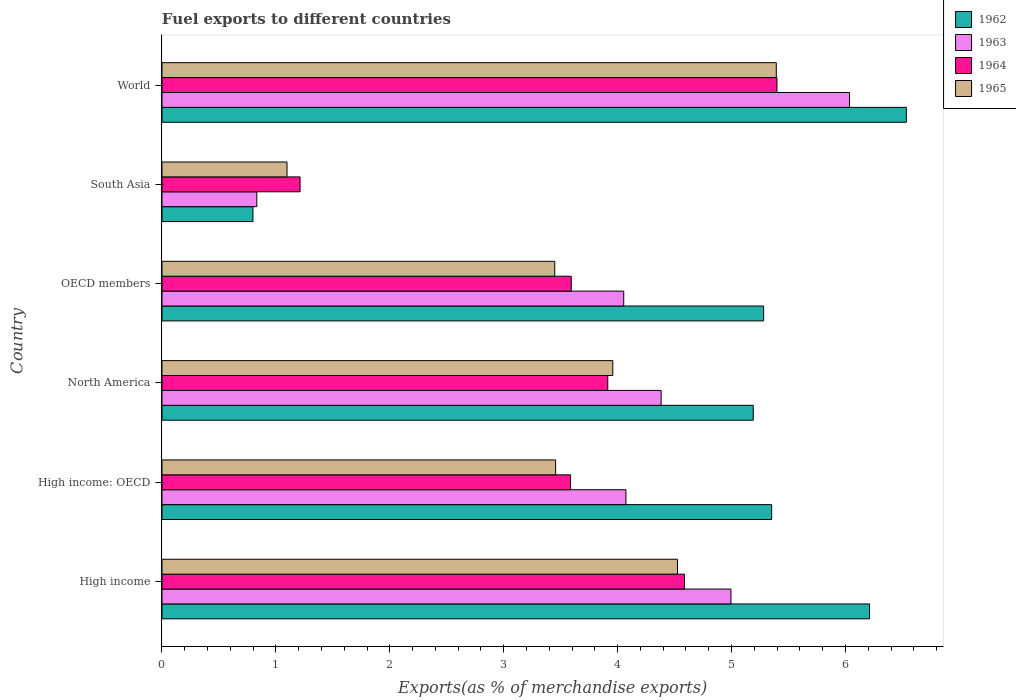How many different coloured bars are there?
Ensure brevity in your answer.  4. How many groups of bars are there?
Keep it short and to the point. 6. Are the number of bars per tick equal to the number of legend labels?
Keep it short and to the point. Yes. Are the number of bars on each tick of the Y-axis equal?
Give a very brief answer. Yes. How many bars are there on the 1st tick from the bottom?
Provide a short and direct response. 4. What is the label of the 2nd group of bars from the top?
Provide a short and direct response. South Asia. What is the percentage of exports to different countries in 1963 in South Asia?
Offer a terse response. 0.83. Across all countries, what is the maximum percentage of exports to different countries in 1965?
Provide a succinct answer. 5.39. Across all countries, what is the minimum percentage of exports to different countries in 1965?
Keep it short and to the point. 1.1. What is the total percentage of exports to different countries in 1963 in the graph?
Offer a very short reply. 24.37. What is the difference between the percentage of exports to different countries in 1962 in High income and that in World?
Ensure brevity in your answer.  -0.32. What is the difference between the percentage of exports to different countries in 1965 in World and the percentage of exports to different countries in 1963 in High income: OECD?
Make the answer very short. 1.32. What is the average percentage of exports to different countries in 1965 per country?
Keep it short and to the point. 3.65. What is the difference between the percentage of exports to different countries in 1963 and percentage of exports to different countries in 1965 in High income: OECD?
Provide a short and direct response. 0.62. In how many countries, is the percentage of exports to different countries in 1962 greater than 1.6 %?
Provide a succinct answer. 5. What is the ratio of the percentage of exports to different countries in 1964 in OECD members to that in World?
Your answer should be very brief. 0.67. Is the percentage of exports to different countries in 1965 in High income less than that in World?
Make the answer very short. Yes. What is the difference between the highest and the second highest percentage of exports to different countries in 1965?
Provide a succinct answer. 0.87. What is the difference between the highest and the lowest percentage of exports to different countries in 1964?
Your answer should be very brief. 4.19. In how many countries, is the percentage of exports to different countries in 1965 greater than the average percentage of exports to different countries in 1965 taken over all countries?
Make the answer very short. 3. What does the 2nd bar from the top in High income: OECD represents?
Give a very brief answer. 1964. What does the 3rd bar from the bottom in High income represents?
Your answer should be compact. 1964. Are all the bars in the graph horizontal?
Your answer should be compact. Yes. How many countries are there in the graph?
Your response must be concise. 6. What is the difference between two consecutive major ticks on the X-axis?
Your response must be concise. 1. Does the graph contain any zero values?
Offer a terse response. No. Where does the legend appear in the graph?
Offer a terse response. Top right. How are the legend labels stacked?
Provide a short and direct response. Vertical. What is the title of the graph?
Offer a very short reply. Fuel exports to different countries. What is the label or title of the X-axis?
Make the answer very short. Exports(as % of merchandise exports). What is the Exports(as % of merchandise exports) in 1962 in High income?
Offer a very short reply. 6.21. What is the Exports(as % of merchandise exports) in 1963 in High income?
Make the answer very short. 5. What is the Exports(as % of merchandise exports) in 1964 in High income?
Give a very brief answer. 4.59. What is the Exports(as % of merchandise exports) in 1965 in High income?
Your response must be concise. 4.53. What is the Exports(as % of merchandise exports) in 1962 in High income: OECD?
Your answer should be compact. 5.35. What is the Exports(as % of merchandise exports) in 1963 in High income: OECD?
Give a very brief answer. 4.07. What is the Exports(as % of merchandise exports) in 1964 in High income: OECD?
Keep it short and to the point. 3.59. What is the Exports(as % of merchandise exports) in 1965 in High income: OECD?
Give a very brief answer. 3.46. What is the Exports(as % of merchandise exports) in 1962 in North America?
Your response must be concise. 5.19. What is the Exports(as % of merchandise exports) in 1963 in North America?
Keep it short and to the point. 4.38. What is the Exports(as % of merchandise exports) in 1964 in North America?
Your answer should be compact. 3.91. What is the Exports(as % of merchandise exports) of 1965 in North America?
Provide a succinct answer. 3.96. What is the Exports(as % of merchandise exports) in 1962 in OECD members?
Give a very brief answer. 5.28. What is the Exports(as % of merchandise exports) in 1963 in OECD members?
Offer a very short reply. 4.05. What is the Exports(as % of merchandise exports) in 1964 in OECD members?
Your response must be concise. 3.59. What is the Exports(as % of merchandise exports) in 1965 in OECD members?
Your answer should be very brief. 3.45. What is the Exports(as % of merchandise exports) of 1962 in South Asia?
Offer a very short reply. 0.8. What is the Exports(as % of merchandise exports) in 1963 in South Asia?
Your response must be concise. 0.83. What is the Exports(as % of merchandise exports) in 1964 in South Asia?
Provide a short and direct response. 1.21. What is the Exports(as % of merchandise exports) in 1965 in South Asia?
Your answer should be very brief. 1.1. What is the Exports(as % of merchandise exports) in 1962 in World?
Give a very brief answer. 6.53. What is the Exports(as % of merchandise exports) of 1963 in World?
Keep it short and to the point. 6.04. What is the Exports(as % of merchandise exports) in 1964 in World?
Provide a short and direct response. 5.4. What is the Exports(as % of merchandise exports) in 1965 in World?
Provide a short and direct response. 5.39. Across all countries, what is the maximum Exports(as % of merchandise exports) in 1962?
Your answer should be compact. 6.53. Across all countries, what is the maximum Exports(as % of merchandise exports) of 1963?
Your response must be concise. 6.04. Across all countries, what is the maximum Exports(as % of merchandise exports) in 1964?
Provide a succinct answer. 5.4. Across all countries, what is the maximum Exports(as % of merchandise exports) in 1965?
Your answer should be very brief. 5.39. Across all countries, what is the minimum Exports(as % of merchandise exports) in 1962?
Offer a terse response. 0.8. Across all countries, what is the minimum Exports(as % of merchandise exports) of 1963?
Offer a very short reply. 0.83. Across all countries, what is the minimum Exports(as % of merchandise exports) in 1964?
Provide a short and direct response. 1.21. Across all countries, what is the minimum Exports(as % of merchandise exports) in 1965?
Keep it short and to the point. 1.1. What is the total Exports(as % of merchandise exports) of 1962 in the graph?
Provide a succinct answer. 29.37. What is the total Exports(as % of merchandise exports) of 1963 in the graph?
Provide a short and direct response. 24.37. What is the total Exports(as % of merchandise exports) in 1964 in the graph?
Provide a short and direct response. 22.29. What is the total Exports(as % of merchandise exports) of 1965 in the graph?
Provide a short and direct response. 21.88. What is the difference between the Exports(as % of merchandise exports) in 1962 in High income and that in High income: OECD?
Make the answer very short. 0.86. What is the difference between the Exports(as % of merchandise exports) of 1963 in High income and that in High income: OECD?
Your answer should be very brief. 0.92. What is the difference between the Exports(as % of merchandise exports) of 1964 in High income and that in High income: OECD?
Your response must be concise. 1. What is the difference between the Exports(as % of merchandise exports) in 1965 in High income and that in High income: OECD?
Provide a short and direct response. 1.07. What is the difference between the Exports(as % of merchandise exports) in 1963 in High income and that in North America?
Ensure brevity in your answer.  0.61. What is the difference between the Exports(as % of merchandise exports) of 1964 in High income and that in North America?
Provide a succinct answer. 0.67. What is the difference between the Exports(as % of merchandise exports) in 1965 in High income and that in North America?
Provide a succinct answer. 0.57. What is the difference between the Exports(as % of merchandise exports) of 1962 in High income and that in OECD members?
Offer a very short reply. 0.93. What is the difference between the Exports(as % of merchandise exports) of 1963 in High income and that in OECD members?
Give a very brief answer. 0.94. What is the difference between the Exports(as % of merchandise exports) in 1965 in High income and that in OECD members?
Give a very brief answer. 1.08. What is the difference between the Exports(as % of merchandise exports) of 1962 in High income and that in South Asia?
Ensure brevity in your answer.  5.41. What is the difference between the Exports(as % of merchandise exports) in 1963 in High income and that in South Asia?
Keep it short and to the point. 4.16. What is the difference between the Exports(as % of merchandise exports) of 1964 in High income and that in South Asia?
Make the answer very short. 3.37. What is the difference between the Exports(as % of merchandise exports) in 1965 in High income and that in South Asia?
Provide a short and direct response. 3.43. What is the difference between the Exports(as % of merchandise exports) of 1962 in High income and that in World?
Offer a terse response. -0.32. What is the difference between the Exports(as % of merchandise exports) of 1963 in High income and that in World?
Provide a succinct answer. -1.04. What is the difference between the Exports(as % of merchandise exports) of 1964 in High income and that in World?
Make the answer very short. -0.81. What is the difference between the Exports(as % of merchandise exports) in 1965 in High income and that in World?
Provide a succinct answer. -0.87. What is the difference between the Exports(as % of merchandise exports) in 1962 in High income: OECD and that in North America?
Offer a very short reply. 0.16. What is the difference between the Exports(as % of merchandise exports) of 1963 in High income: OECD and that in North America?
Ensure brevity in your answer.  -0.31. What is the difference between the Exports(as % of merchandise exports) of 1964 in High income: OECD and that in North America?
Make the answer very short. -0.33. What is the difference between the Exports(as % of merchandise exports) in 1965 in High income: OECD and that in North America?
Your response must be concise. -0.5. What is the difference between the Exports(as % of merchandise exports) of 1962 in High income: OECD and that in OECD members?
Your answer should be compact. 0.07. What is the difference between the Exports(as % of merchandise exports) in 1963 in High income: OECD and that in OECD members?
Your answer should be compact. 0.02. What is the difference between the Exports(as % of merchandise exports) of 1964 in High income: OECD and that in OECD members?
Make the answer very short. -0.01. What is the difference between the Exports(as % of merchandise exports) in 1965 in High income: OECD and that in OECD members?
Offer a very short reply. 0.01. What is the difference between the Exports(as % of merchandise exports) in 1962 in High income: OECD and that in South Asia?
Your answer should be compact. 4.55. What is the difference between the Exports(as % of merchandise exports) in 1963 in High income: OECD and that in South Asia?
Give a very brief answer. 3.24. What is the difference between the Exports(as % of merchandise exports) in 1964 in High income: OECD and that in South Asia?
Provide a short and direct response. 2.37. What is the difference between the Exports(as % of merchandise exports) in 1965 in High income: OECD and that in South Asia?
Ensure brevity in your answer.  2.36. What is the difference between the Exports(as % of merchandise exports) of 1962 in High income: OECD and that in World?
Provide a short and direct response. -1.18. What is the difference between the Exports(as % of merchandise exports) of 1963 in High income: OECD and that in World?
Provide a short and direct response. -1.96. What is the difference between the Exports(as % of merchandise exports) of 1964 in High income: OECD and that in World?
Your answer should be very brief. -1.81. What is the difference between the Exports(as % of merchandise exports) of 1965 in High income: OECD and that in World?
Give a very brief answer. -1.94. What is the difference between the Exports(as % of merchandise exports) in 1962 in North America and that in OECD members?
Your response must be concise. -0.09. What is the difference between the Exports(as % of merchandise exports) in 1963 in North America and that in OECD members?
Your answer should be compact. 0.33. What is the difference between the Exports(as % of merchandise exports) in 1964 in North America and that in OECD members?
Offer a terse response. 0.32. What is the difference between the Exports(as % of merchandise exports) in 1965 in North America and that in OECD members?
Make the answer very short. 0.51. What is the difference between the Exports(as % of merchandise exports) in 1962 in North America and that in South Asia?
Your answer should be compact. 4.39. What is the difference between the Exports(as % of merchandise exports) in 1963 in North America and that in South Asia?
Ensure brevity in your answer.  3.55. What is the difference between the Exports(as % of merchandise exports) in 1964 in North America and that in South Asia?
Offer a terse response. 2.7. What is the difference between the Exports(as % of merchandise exports) in 1965 in North America and that in South Asia?
Provide a short and direct response. 2.86. What is the difference between the Exports(as % of merchandise exports) of 1962 in North America and that in World?
Provide a short and direct response. -1.34. What is the difference between the Exports(as % of merchandise exports) of 1963 in North America and that in World?
Keep it short and to the point. -1.65. What is the difference between the Exports(as % of merchandise exports) of 1964 in North America and that in World?
Your response must be concise. -1.49. What is the difference between the Exports(as % of merchandise exports) of 1965 in North America and that in World?
Give a very brief answer. -1.44. What is the difference between the Exports(as % of merchandise exports) in 1962 in OECD members and that in South Asia?
Give a very brief answer. 4.48. What is the difference between the Exports(as % of merchandise exports) in 1963 in OECD members and that in South Asia?
Ensure brevity in your answer.  3.22. What is the difference between the Exports(as % of merchandise exports) of 1964 in OECD members and that in South Asia?
Keep it short and to the point. 2.38. What is the difference between the Exports(as % of merchandise exports) of 1965 in OECD members and that in South Asia?
Offer a terse response. 2.35. What is the difference between the Exports(as % of merchandise exports) in 1962 in OECD members and that in World?
Provide a short and direct response. -1.25. What is the difference between the Exports(as % of merchandise exports) of 1963 in OECD members and that in World?
Keep it short and to the point. -1.98. What is the difference between the Exports(as % of merchandise exports) of 1964 in OECD members and that in World?
Offer a terse response. -1.81. What is the difference between the Exports(as % of merchandise exports) in 1965 in OECD members and that in World?
Your response must be concise. -1.94. What is the difference between the Exports(as % of merchandise exports) in 1962 in South Asia and that in World?
Your answer should be very brief. -5.74. What is the difference between the Exports(as % of merchandise exports) in 1963 in South Asia and that in World?
Offer a terse response. -5.2. What is the difference between the Exports(as % of merchandise exports) of 1964 in South Asia and that in World?
Your response must be concise. -4.19. What is the difference between the Exports(as % of merchandise exports) in 1965 in South Asia and that in World?
Offer a very short reply. -4.3. What is the difference between the Exports(as % of merchandise exports) in 1962 in High income and the Exports(as % of merchandise exports) in 1963 in High income: OECD?
Your answer should be very brief. 2.14. What is the difference between the Exports(as % of merchandise exports) of 1962 in High income and the Exports(as % of merchandise exports) of 1964 in High income: OECD?
Ensure brevity in your answer.  2.62. What is the difference between the Exports(as % of merchandise exports) in 1962 in High income and the Exports(as % of merchandise exports) in 1965 in High income: OECD?
Make the answer very short. 2.76. What is the difference between the Exports(as % of merchandise exports) of 1963 in High income and the Exports(as % of merchandise exports) of 1964 in High income: OECD?
Make the answer very short. 1.41. What is the difference between the Exports(as % of merchandise exports) in 1963 in High income and the Exports(as % of merchandise exports) in 1965 in High income: OECD?
Offer a terse response. 1.54. What is the difference between the Exports(as % of merchandise exports) of 1964 in High income and the Exports(as % of merchandise exports) of 1965 in High income: OECD?
Your response must be concise. 1.13. What is the difference between the Exports(as % of merchandise exports) of 1962 in High income and the Exports(as % of merchandise exports) of 1963 in North America?
Give a very brief answer. 1.83. What is the difference between the Exports(as % of merchandise exports) of 1962 in High income and the Exports(as % of merchandise exports) of 1964 in North America?
Offer a very short reply. 2.3. What is the difference between the Exports(as % of merchandise exports) of 1962 in High income and the Exports(as % of merchandise exports) of 1965 in North America?
Provide a succinct answer. 2.25. What is the difference between the Exports(as % of merchandise exports) in 1963 in High income and the Exports(as % of merchandise exports) in 1964 in North America?
Give a very brief answer. 1.08. What is the difference between the Exports(as % of merchandise exports) in 1963 in High income and the Exports(as % of merchandise exports) in 1965 in North America?
Offer a terse response. 1.04. What is the difference between the Exports(as % of merchandise exports) of 1964 in High income and the Exports(as % of merchandise exports) of 1965 in North America?
Offer a very short reply. 0.63. What is the difference between the Exports(as % of merchandise exports) of 1962 in High income and the Exports(as % of merchandise exports) of 1963 in OECD members?
Provide a succinct answer. 2.16. What is the difference between the Exports(as % of merchandise exports) in 1962 in High income and the Exports(as % of merchandise exports) in 1964 in OECD members?
Provide a succinct answer. 2.62. What is the difference between the Exports(as % of merchandise exports) of 1962 in High income and the Exports(as % of merchandise exports) of 1965 in OECD members?
Offer a very short reply. 2.76. What is the difference between the Exports(as % of merchandise exports) in 1963 in High income and the Exports(as % of merchandise exports) in 1964 in OECD members?
Your answer should be very brief. 1.4. What is the difference between the Exports(as % of merchandise exports) of 1963 in High income and the Exports(as % of merchandise exports) of 1965 in OECD members?
Give a very brief answer. 1.55. What is the difference between the Exports(as % of merchandise exports) in 1964 in High income and the Exports(as % of merchandise exports) in 1965 in OECD members?
Provide a succinct answer. 1.14. What is the difference between the Exports(as % of merchandise exports) of 1962 in High income and the Exports(as % of merchandise exports) of 1963 in South Asia?
Ensure brevity in your answer.  5.38. What is the difference between the Exports(as % of merchandise exports) of 1962 in High income and the Exports(as % of merchandise exports) of 1964 in South Asia?
Make the answer very short. 5. What is the difference between the Exports(as % of merchandise exports) in 1962 in High income and the Exports(as % of merchandise exports) in 1965 in South Asia?
Keep it short and to the point. 5.11. What is the difference between the Exports(as % of merchandise exports) in 1963 in High income and the Exports(as % of merchandise exports) in 1964 in South Asia?
Make the answer very short. 3.78. What is the difference between the Exports(as % of merchandise exports) of 1963 in High income and the Exports(as % of merchandise exports) of 1965 in South Asia?
Make the answer very short. 3.9. What is the difference between the Exports(as % of merchandise exports) in 1964 in High income and the Exports(as % of merchandise exports) in 1965 in South Asia?
Provide a short and direct response. 3.49. What is the difference between the Exports(as % of merchandise exports) of 1962 in High income and the Exports(as % of merchandise exports) of 1963 in World?
Provide a succinct answer. 0.18. What is the difference between the Exports(as % of merchandise exports) of 1962 in High income and the Exports(as % of merchandise exports) of 1964 in World?
Make the answer very short. 0.81. What is the difference between the Exports(as % of merchandise exports) in 1962 in High income and the Exports(as % of merchandise exports) in 1965 in World?
Offer a terse response. 0.82. What is the difference between the Exports(as % of merchandise exports) of 1963 in High income and the Exports(as % of merchandise exports) of 1964 in World?
Your response must be concise. -0.4. What is the difference between the Exports(as % of merchandise exports) of 1963 in High income and the Exports(as % of merchandise exports) of 1965 in World?
Provide a short and direct response. -0.4. What is the difference between the Exports(as % of merchandise exports) of 1964 in High income and the Exports(as % of merchandise exports) of 1965 in World?
Ensure brevity in your answer.  -0.81. What is the difference between the Exports(as % of merchandise exports) in 1962 in High income: OECD and the Exports(as % of merchandise exports) in 1963 in North America?
Ensure brevity in your answer.  0.97. What is the difference between the Exports(as % of merchandise exports) of 1962 in High income: OECD and the Exports(as % of merchandise exports) of 1964 in North America?
Keep it short and to the point. 1.44. What is the difference between the Exports(as % of merchandise exports) of 1962 in High income: OECD and the Exports(as % of merchandise exports) of 1965 in North America?
Offer a very short reply. 1.39. What is the difference between the Exports(as % of merchandise exports) of 1963 in High income: OECD and the Exports(as % of merchandise exports) of 1964 in North America?
Provide a succinct answer. 0.16. What is the difference between the Exports(as % of merchandise exports) in 1963 in High income: OECD and the Exports(as % of merchandise exports) in 1965 in North America?
Ensure brevity in your answer.  0.12. What is the difference between the Exports(as % of merchandise exports) of 1964 in High income: OECD and the Exports(as % of merchandise exports) of 1965 in North America?
Give a very brief answer. -0.37. What is the difference between the Exports(as % of merchandise exports) in 1962 in High income: OECD and the Exports(as % of merchandise exports) in 1963 in OECD members?
Your answer should be very brief. 1.3. What is the difference between the Exports(as % of merchandise exports) of 1962 in High income: OECD and the Exports(as % of merchandise exports) of 1964 in OECD members?
Your answer should be very brief. 1.76. What is the difference between the Exports(as % of merchandise exports) of 1962 in High income: OECD and the Exports(as % of merchandise exports) of 1965 in OECD members?
Ensure brevity in your answer.  1.9. What is the difference between the Exports(as % of merchandise exports) of 1963 in High income: OECD and the Exports(as % of merchandise exports) of 1964 in OECD members?
Offer a very short reply. 0.48. What is the difference between the Exports(as % of merchandise exports) of 1963 in High income: OECD and the Exports(as % of merchandise exports) of 1965 in OECD members?
Ensure brevity in your answer.  0.62. What is the difference between the Exports(as % of merchandise exports) in 1964 in High income: OECD and the Exports(as % of merchandise exports) in 1965 in OECD members?
Your answer should be compact. 0.14. What is the difference between the Exports(as % of merchandise exports) of 1962 in High income: OECD and the Exports(as % of merchandise exports) of 1963 in South Asia?
Provide a short and direct response. 4.52. What is the difference between the Exports(as % of merchandise exports) in 1962 in High income: OECD and the Exports(as % of merchandise exports) in 1964 in South Asia?
Provide a short and direct response. 4.14. What is the difference between the Exports(as % of merchandise exports) of 1962 in High income: OECD and the Exports(as % of merchandise exports) of 1965 in South Asia?
Make the answer very short. 4.25. What is the difference between the Exports(as % of merchandise exports) of 1963 in High income: OECD and the Exports(as % of merchandise exports) of 1964 in South Asia?
Keep it short and to the point. 2.86. What is the difference between the Exports(as % of merchandise exports) of 1963 in High income: OECD and the Exports(as % of merchandise exports) of 1965 in South Asia?
Keep it short and to the point. 2.98. What is the difference between the Exports(as % of merchandise exports) of 1964 in High income: OECD and the Exports(as % of merchandise exports) of 1965 in South Asia?
Offer a very short reply. 2.49. What is the difference between the Exports(as % of merchandise exports) of 1962 in High income: OECD and the Exports(as % of merchandise exports) of 1963 in World?
Keep it short and to the point. -0.68. What is the difference between the Exports(as % of merchandise exports) in 1962 in High income: OECD and the Exports(as % of merchandise exports) in 1964 in World?
Offer a terse response. -0.05. What is the difference between the Exports(as % of merchandise exports) in 1962 in High income: OECD and the Exports(as % of merchandise exports) in 1965 in World?
Your response must be concise. -0.04. What is the difference between the Exports(as % of merchandise exports) in 1963 in High income: OECD and the Exports(as % of merchandise exports) in 1964 in World?
Your response must be concise. -1.33. What is the difference between the Exports(as % of merchandise exports) of 1963 in High income: OECD and the Exports(as % of merchandise exports) of 1965 in World?
Give a very brief answer. -1.32. What is the difference between the Exports(as % of merchandise exports) in 1964 in High income: OECD and the Exports(as % of merchandise exports) in 1965 in World?
Offer a very short reply. -1.81. What is the difference between the Exports(as % of merchandise exports) in 1962 in North America and the Exports(as % of merchandise exports) in 1963 in OECD members?
Offer a terse response. 1.14. What is the difference between the Exports(as % of merchandise exports) of 1962 in North America and the Exports(as % of merchandise exports) of 1964 in OECD members?
Keep it short and to the point. 1.6. What is the difference between the Exports(as % of merchandise exports) of 1962 in North America and the Exports(as % of merchandise exports) of 1965 in OECD members?
Keep it short and to the point. 1.74. What is the difference between the Exports(as % of merchandise exports) of 1963 in North America and the Exports(as % of merchandise exports) of 1964 in OECD members?
Your answer should be very brief. 0.79. What is the difference between the Exports(as % of merchandise exports) of 1963 in North America and the Exports(as % of merchandise exports) of 1965 in OECD members?
Make the answer very short. 0.93. What is the difference between the Exports(as % of merchandise exports) of 1964 in North America and the Exports(as % of merchandise exports) of 1965 in OECD members?
Keep it short and to the point. 0.47. What is the difference between the Exports(as % of merchandise exports) in 1962 in North America and the Exports(as % of merchandise exports) in 1963 in South Asia?
Keep it short and to the point. 4.36. What is the difference between the Exports(as % of merchandise exports) in 1962 in North America and the Exports(as % of merchandise exports) in 1964 in South Asia?
Offer a terse response. 3.98. What is the difference between the Exports(as % of merchandise exports) in 1962 in North America and the Exports(as % of merchandise exports) in 1965 in South Asia?
Make the answer very short. 4.09. What is the difference between the Exports(as % of merchandise exports) in 1963 in North America and the Exports(as % of merchandise exports) in 1964 in South Asia?
Make the answer very short. 3.17. What is the difference between the Exports(as % of merchandise exports) in 1963 in North America and the Exports(as % of merchandise exports) in 1965 in South Asia?
Provide a short and direct response. 3.28. What is the difference between the Exports(as % of merchandise exports) of 1964 in North America and the Exports(as % of merchandise exports) of 1965 in South Asia?
Give a very brief answer. 2.82. What is the difference between the Exports(as % of merchandise exports) in 1962 in North America and the Exports(as % of merchandise exports) in 1963 in World?
Your response must be concise. -0.85. What is the difference between the Exports(as % of merchandise exports) in 1962 in North America and the Exports(as % of merchandise exports) in 1964 in World?
Your response must be concise. -0.21. What is the difference between the Exports(as % of merchandise exports) of 1962 in North America and the Exports(as % of merchandise exports) of 1965 in World?
Your response must be concise. -0.2. What is the difference between the Exports(as % of merchandise exports) of 1963 in North America and the Exports(as % of merchandise exports) of 1964 in World?
Your answer should be compact. -1.02. What is the difference between the Exports(as % of merchandise exports) of 1963 in North America and the Exports(as % of merchandise exports) of 1965 in World?
Give a very brief answer. -1.01. What is the difference between the Exports(as % of merchandise exports) of 1964 in North America and the Exports(as % of merchandise exports) of 1965 in World?
Keep it short and to the point. -1.48. What is the difference between the Exports(as % of merchandise exports) of 1962 in OECD members and the Exports(as % of merchandise exports) of 1963 in South Asia?
Provide a succinct answer. 4.45. What is the difference between the Exports(as % of merchandise exports) of 1962 in OECD members and the Exports(as % of merchandise exports) of 1964 in South Asia?
Your response must be concise. 4.07. What is the difference between the Exports(as % of merchandise exports) in 1962 in OECD members and the Exports(as % of merchandise exports) in 1965 in South Asia?
Offer a very short reply. 4.18. What is the difference between the Exports(as % of merchandise exports) in 1963 in OECD members and the Exports(as % of merchandise exports) in 1964 in South Asia?
Offer a terse response. 2.84. What is the difference between the Exports(as % of merchandise exports) of 1963 in OECD members and the Exports(as % of merchandise exports) of 1965 in South Asia?
Provide a succinct answer. 2.96. What is the difference between the Exports(as % of merchandise exports) of 1964 in OECD members and the Exports(as % of merchandise exports) of 1965 in South Asia?
Provide a short and direct response. 2.5. What is the difference between the Exports(as % of merchandise exports) of 1962 in OECD members and the Exports(as % of merchandise exports) of 1963 in World?
Make the answer very short. -0.75. What is the difference between the Exports(as % of merchandise exports) of 1962 in OECD members and the Exports(as % of merchandise exports) of 1964 in World?
Provide a short and direct response. -0.12. What is the difference between the Exports(as % of merchandise exports) of 1962 in OECD members and the Exports(as % of merchandise exports) of 1965 in World?
Provide a succinct answer. -0.11. What is the difference between the Exports(as % of merchandise exports) in 1963 in OECD members and the Exports(as % of merchandise exports) in 1964 in World?
Provide a short and direct response. -1.35. What is the difference between the Exports(as % of merchandise exports) of 1963 in OECD members and the Exports(as % of merchandise exports) of 1965 in World?
Your answer should be compact. -1.34. What is the difference between the Exports(as % of merchandise exports) of 1964 in OECD members and the Exports(as % of merchandise exports) of 1965 in World?
Make the answer very short. -1.8. What is the difference between the Exports(as % of merchandise exports) in 1962 in South Asia and the Exports(as % of merchandise exports) in 1963 in World?
Your answer should be compact. -5.24. What is the difference between the Exports(as % of merchandise exports) in 1962 in South Asia and the Exports(as % of merchandise exports) in 1964 in World?
Your answer should be very brief. -4.6. What is the difference between the Exports(as % of merchandise exports) of 1962 in South Asia and the Exports(as % of merchandise exports) of 1965 in World?
Make the answer very short. -4.59. What is the difference between the Exports(as % of merchandise exports) of 1963 in South Asia and the Exports(as % of merchandise exports) of 1964 in World?
Give a very brief answer. -4.57. What is the difference between the Exports(as % of merchandise exports) of 1963 in South Asia and the Exports(as % of merchandise exports) of 1965 in World?
Your answer should be compact. -4.56. What is the difference between the Exports(as % of merchandise exports) in 1964 in South Asia and the Exports(as % of merchandise exports) in 1965 in World?
Your answer should be compact. -4.18. What is the average Exports(as % of merchandise exports) in 1962 per country?
Offer a very short reply. 4.9. What is the average Exports(as % of merchandise exports) of 1963 per country?
Your answer should be compact. 4.06. What is the average Exports(as % of merchandise exports) of 1964 per country?
Offer a very short reply. 3.72. What is the average Exports(as % of merchandise exports) in 1965 per country?
Give a very brief answer. 3.65. What is the difference between the Exports(as % of merchandise exports) in 1962 and Exports(as % of merchandise exports) in 1963 in High income?
Make the answer very short. 1.22. What is the difference between the Exports(as % of merchandise exports) in 1962 and Exports(as % of merchandise exports) in 1964 in High income?
Give a very brief answer. 1.63. What is the difference between the Exports(as % of merchandise exports) in 1962 and Exports(as % of merchandise exports) in 1965 in High income?
Your answer should be very brief. 1.69. What is the difference between the Exports(as % of merchandise exports) in 1963 and Exports(as % of merchandise exports) in 1964 in High income?
Your answer should be very brief. 0.41. What is the difference between the Exports(as % of merchandise exports) of 1963 and Exports(as % of merchandise exports) of 1965 in High income?
Offer a terse response. 0.47. What is the difference between the Exports(as % of merchandise exports) of 1964 and Exports(as % of merchandise exports) of 1965 in High income?
Keep it short and to the point. 0.06. What is the difference between the Exports(as % of merchandise exports) in 1962 and Exports(as % of merchandise exports) in 1963 in High income: OECD?
Your answer should be very brief. 1.28. What is the difference between the Exports(as % of merchandise exports) of 1962 and Exports(as % of merchandise exports) of 1964 in High income: OECD?
Keep it short and to the point. 1.77. What is the difference between the Exports(as % of merchandise exports) of 1962 and Exports(as % of merchandise exports) of 1965 in High income: OECD?
Your answer should be very brief. 1.9. What is the difference between the Exports(as % of merchandise exports) of 1963 and Exports(as % of merchandise exports) of 1964 in High income: OECD?
Keep it short and to the point. 0.49. What is the difference between the Exports(as % of merchandise exports) of 1963 and Exports(as % of merchandise exports) of 1965 in High income: OECD?
Your response must be concise. 0.62. What is the difference between the Exports(as % of merchandise exports) in 1964 and Exports(as % of merchandise exports) in 1965 in High income: OECD?
Offer a terse response. 0.13. What is the difference between the Exports(as % of merchandise exports) in 1962 and Exports(as % of merchandise exports) in 1963 in North America?
Provide a short and direct response. 0.81. What is the difference between the Exports(as % of merchandise exports) in 1962 and Exports(as % of merchandise exports) in 1964 in North America?
Offer a very short reply. 1.28. What is the difference between the Exports(as % of merchandise exports) of 1962 and Exports(as % of merchandise exports) of 1965 in North America?
Your response must be concise. 1.23. What is the difference between the Exports(as % of merchandise exports) in 1963 and Exports(as % of merchandise exports) in 1964 in North America?
Ensure brevity in your answer.  0.47. What is the difference between the Exports(as % of merchandise exports) of 1963 and Exports(as % of merchandise exports) of 1965 in North America?
Offer a very short reply. 0.42. What is the difference between the Exports(as % of merchandise exports) of 1964 and Exports(as % of merchandise exports) of 1965 in North America?
Make the answer very short. -0.04. What is the difference between the Exports(as % of merchandise exports) in 1962 and Exports(as % of merchandise exports) in 1963 in OECD members?
Provide a succinct answer. 1.23. What is the difference between the Exports(as % of merchandise exports) of 1962 and Exports(as % of merchandise exports) of 1964 in OECD members?
Make the answer very short. 1.69. What is the difference between the Exports(as % of merchandise exports) of 1962 and Exports(as % of merchandise exports) of 1965 in OECD members?
Make the answer very short. 1.83. What is the difference between the Exports(as % of merchandise exports) in 1963 and Exports(as % of merchandise exports) in 1964 in OECD members?
Make the answer very short. 0.46. What is the difference between the Exports(as % of merchandise exports) in 1963 and Exports(as % of merchandise exports) in 1965 in OECD members?
Ensure brevity in your answer.  0.61. What is the difference between the Exports(as % of merchandise exports) in 1964 and Exports(as % of merchandise exports) in 1965 in OECD members?
Give a very brief answer. 0.14. What is the difference between the Exports(as % of merchandise exports) of 1962 and Exports(as % of merchandise exports) of 1963 in South Asia?
Give a very brief answer. -0.03. What is the difference between the Exports(as % of merchandise exports) in 1962 and Exports(as % of merchandise exports) in 1964 in South Asia?
Ensure brevity in your answer.  -0.41. What is the difference between the Exports(as % of merchandise exports) of 1962 and Exports(as % of merchandise exports) of 1965 in South Asia?
Offer a very short reply. -0.3. What is the difference between the Exports(as % of merchandise exports) of 1963 and Exports(as % of merchandise exports) of 1964 in South Asia?
Make the answer very short. -0.38. What is the difference between the Exports(as % of merchandise exports) of 1963 and Exports(as % of merchandise exports) of 1965 in South Asia?
Provide a succinct answer. -0.27. What is the difference between the Exports(as % of merchandise exports) of 1964 and Exports(as % of merchandise exports) of 1965 in South Asia?
Give a very brief answer. 0.11. What is the difference between the Exports(as % of merchandise exports) of 1962 and Exports(as % of merchandise exports) of 1963 in World?
Provide a succinct answer. 0.5. What is the difference between the Exports(as % of merchandise exports) of 1962 and Exports(as % of merchandise exports) of 1964 in World?
Your answer should be very brief. 1.14. What is the difference between the Exports(as % of merchandise exports) of 1962 and Exports(as % of merchandise exports) of 1965 in World?
Provide a short and direct response. 1.14. What is the difference between the Exports(as % of merchandise exports) of 1963 and Exports(as % of merchandise exports) of 1964 in World?
Ensure brevity in your answer.  0.64. What is the difference between the Exports(as % of merchandise exports) in 1963 and Exports(as % of merchandise exports) in 1965 in World?
Keep it short and to the point. 0.64. What is the difference between the Exports(as % of merchandise exports) of 1964 and Exports(as % of merchandise exports) of 1965 in World?
Ensure brevity in your answer.  0.01. What is the ratio of the Exports(as % of merchandise exports) of 1962 in High income to that in High income: OECD?
Offer a terse response. 1.16. What is the ratio of the Exports(as % of merchandise exports) of 1963 in High income to that in High income: OECD?
Offer a very short reply. 1.23. What is the ratio of the Exports(as % of merchandise exports) in 1964 in High income to that in High income: OECD?
Keep it short and to the point. 1.28. What is the ratio of the Exports(as % of merchandise exports) of 1965 in High income to that in High income: OECD?
Make the answer very short. 1.31. What is the ratio of the Exports(as % of merchandise exports) of 1962 in High income to that in North America?
Your answer should be compact. 1.2. What is the ratio of the Exports(as % of merchandise exports) in 1963 in High income to that in North America?
Keep it short and to the point. 1.14. What is the ratio of the Exports(as % of merchandise exports) in 1964 in High income to that in North America?
Offer a terse response. 1.17. What is the ratio of the Exports(as % of merchandise exports) in 1965 in High income to that in North America?
Offer a terse response. 1.14. What is the ratio of the Exports(as % of merchandise exports) in 1962 in High income to that in OECD members?
Provide a short and direct response. 1.18. What is the ratio of the Exports(as % of merchandise exports) in 1963 in High income to that in OECD members?
Your answer should be compact. 1.23. What is the ratio of the Exports(as % of merchandise exports) in 1964 in High income to that in OECD members?
Give a very brief answer. 1.28. What is the ratio of the Exports(as % of merchandise exports) of 1965 in High income to that in OECD members?
Give a very brief answer. 1.31. What is the ratio of the Exports(as % of merchandise exports) in 1962 in High income to that in South Asia?
Provide a succinct answer. 7.78. What is the ratio of the Exports(as % of merchandise exports) of 1963 in High income to that in South Asia?
Your response must be concise. 6. What is the ratio of the Exports(as % of merchandise exports) in 1964 in High income to that in South Asia?
Provide a short and direct response. 3.78. What is the ratio of the Exports(as % of merchandise exports) of 1965 in High income to that in South Asia?
Offer a very short reply. 4.12. What is the ratio of the Exports(as % of merchandise exports) of 1962 in High income to that in World?
Provide a succinct answer. 0.95. What is the ratio of the Exports(as % of merchandise exports) in 1963 in High income to that in World?
Your response must be concise. 0.83. What is the ratio of the Exports(as % of merchandise exports) in 1964 in High income to that in World?
Your response must be concise. 0.85. What is the ratio of the Exports(as % of merchandise exports) of 1965 in High income to that in World?
Your response must be concise. 0.84. What is the ratio of the Exports(as % of merchandise exports) in 1962 in High income: OECD to that in North America?
Provide a short and direct response. 1.03. What is the ratio of the Exports(as % of merchandise exports) in 1963 in High income: OECD to that in North America?
Ensure brevity in your answer.  0.93. What is the ratio of the Exports(as % of merchandise exports) of 1964 in High income: OECD to that in North America?
Keep it short and to the point. 0.92. What is the ratio of the Exports(as % of merchandise exports) of 1965 in High income: OECD to that in North America?
Keep it short and to the point. 0.87. What is the ratio of the Exports(as % of merchandise exports) in 1962 in High income: OECD to that in OECD members?
Your answer should be very brief. 1.01. What is the ratio of the Exports(as % of merchandise exports) in 1963 in High income: OECD to that in OECD members?
Your response must be concise. 1. What is the ratio of the Exports(as % of merchandise exports) of 1965 in High income: OECD to that in OECD members?
Provide a succinct answer. 1. What is the ratio of the Exports(as % of merchandise exports) of 1962 in High income: OECD to that in South Asia?
Give a very brief answer. 6.7. What is the ratio of the Exports(as % of merchandise exports) of 1963 in High income: OECD to that in South Asia?
Your answer should be compact. 4.89. What is the ratio of the Exports(as % of merchandise exports) of 1964 in High income: OECD to that in South Asia?
Your answer should be compact. 2.96. What is the ratio of the Exports(as % of merchandise exports) in 1965 in High income: OECD to that in South Asia?
Provide a succinct answer. 3.15. What is the ratio of the Exports(as % of merchandise exports) in 1962 in High income: OECD to that in World?
Give a very brief answer. 0.82. What is the ratio of the Exports(as % of merchandise exports) in 1963 in High income: OECD to that in World?
Provide a short and direct response. 0.67. What is the ratio of the Exports(as % of merchandise exports) of 1964 in High income: OECD to that in World?
Give a very brief answer. 0.66. What is the ratio of the Exports(as % of merchandise exports) of 1965 in High income: OECD to that in World?
Keep it short and to the point. 0.64. What is the ratio of the Exports(as % of merchandise exports) in 1962 in North America to that in OECD members?
Provide a short and direct response. 0.98. What is the ratio of the Exports(as % of merchandise exports) in 1963 in North America to that in OECD members?
Provide a succinct answer. 1.08. What is the ratio of the Exports(as % of merchandise exports) in 1964 in North America to that in OECD members?
Offer a very short reply. 1.09. What is the ratio of the Exports(as % of merchandise exports) of 1965 in North America to that in OECD members?
Provide a succinct answer. 1.15. What is the ratio of the Exports(as % of merchandise exports) in 1962 in North America to that in South Asia?
Offer a terse response. 6.5. What is the ratio of the Exports(as % of merchandise exports) in 1963 in North America to that in South Asia?
Make the answer very short. 5.26. What is the ratio of the Exports(as % of merchandise exports) of 1964 in North America to that in South Asia?
Offer a terse response. 3.23. What is the ratio of the Exports(as % of merchandise exports) of 1965 in North America to that in South Asia?
Ensure brevity in your answer.  3.61. What is the ratio of the Exports(as % of merchandise exports) of 1962 in North America to that in World?
Your response must be concise. 0.79. What is the ratio of the Exports(as % of merchandise exports) in 1963 in North America to that in World?
Provide a short and direct response. 0.73. What is the ratio of the Exports(as % of merchandise exports) of 1964 in North America to that in World?
Your answer should be compact. 0.72. What is the ratio of the Exports(as % of merchandise exports) in 1965 in North America to that in World?
Make the answer very short. 0.73. What is the ratio of the Exports(as % of merchandise exports) of 1962 in OECD members to that in South Asia?
Offer a very short reply. 6.61. What is the ratio of the Exports(as % of merchandise exports) of 1963 in OECD members to that in South Asia?
Provide a succinct answer. 4.87. What is the ratio of the Exports(as % of merchandise exports) of 1964 in OECD members to that in South Asia?
Provide a short and direct response. 2.96. What is the ratio of the Exports(as % of merchandise exports) in 1965 in OECD members to that in South Asia?
Your answer should be very brief. 3.14. What is the ratio of the Exports(as % of merchandise exports) in 1962 in OECD members to that in World?
Your answer should be compact. 0.81. What is the ratio of the Exports(as % of merchandise exports) of 1963 in OECD members to that in World?
Ensure brevity in your answer.  0.67. What is the ratio of the Exports(as % of merchandise exports) in 1964 in OECD members to that in World?
Your response must be concise. 0.67. What is the ratio of the Exports(as % of merchandise exports) of 1965 in OECD members to that in World?
Your answer should be compact. 0.64. What is the ratio of the Exports(as % of merchandise exports) in 1962 in South Asia to that in World?
Ensure brevity in your answer.  0.12. What is the ratio of the Exports(as % of merchandise exports) in 1963 in South Asia to that in World?
Keep it short and to the point. 0.14. What is the ratio of the Exports(as % of merchandise exports) of 1964 in South Asia to that in World?
Give a very brief answer. 0.22. What is the ratio of the Exports(as % of merchandise exports) of 1965 in South Asia to that in World?
Offer a very short reply. 0.2. What is the difference between the highest and the second highest Exports(as % of merchandise exports) in 1962?
Keep it short and to the point. 0.32. What is the difference between the highest and the second highest Exports(as % of merchandise exports) in 1963?
Make the answer very short. 1.04. What is the difference between the highest and the second highest Exports(as % of merchandise exports) in 1964?
Provide a succinct answer. 0.81. What is the difference between the highest and the second highest Exports(as % of merchandise exports) of 1965?
Make the answer very short. 0.87. What is the difference between the highest and the lowest Exports(as % of merchandise exports) of 1962?
Offer a terse response. 5.74. What is the difference between the highest and the lowest Exports(as % of merchandise exports) of 1963?
Provide a short and direct response. 5.2. What is the difference between the highest and the lowest Exports(as % of merchandise exports) in 1964?
Offer a terse response. 4.19. What is the difference between the highest and the lowest Exports(as % of merchandise exports) of 1965?
Keep it short and to the point. 4.3. 